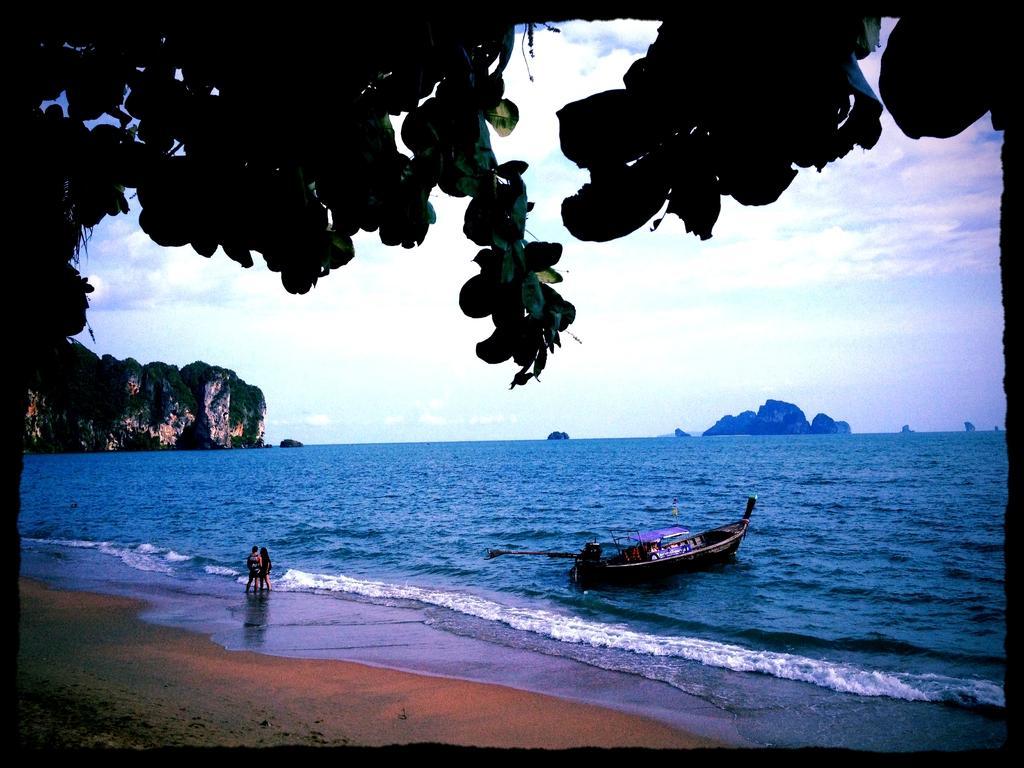Describe this image in one or two sentences. In this image in front there is a tree. At the bottom of the image there is sand. There are two people standing in the water. There is a boat in the water. In the background of the image there are mountains and sky. 